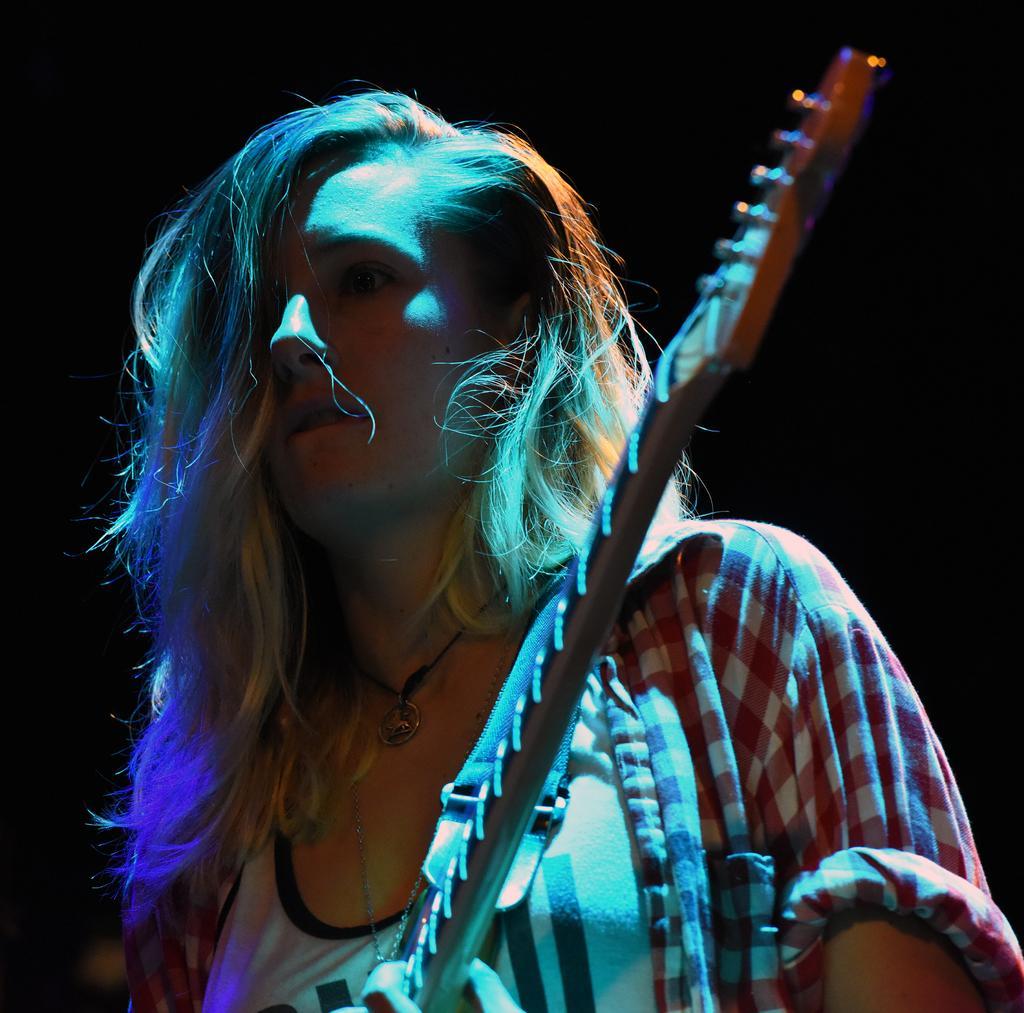In one or two sentences, can you explain what this image depicts? In the given image we can see a girl and a guitar. 